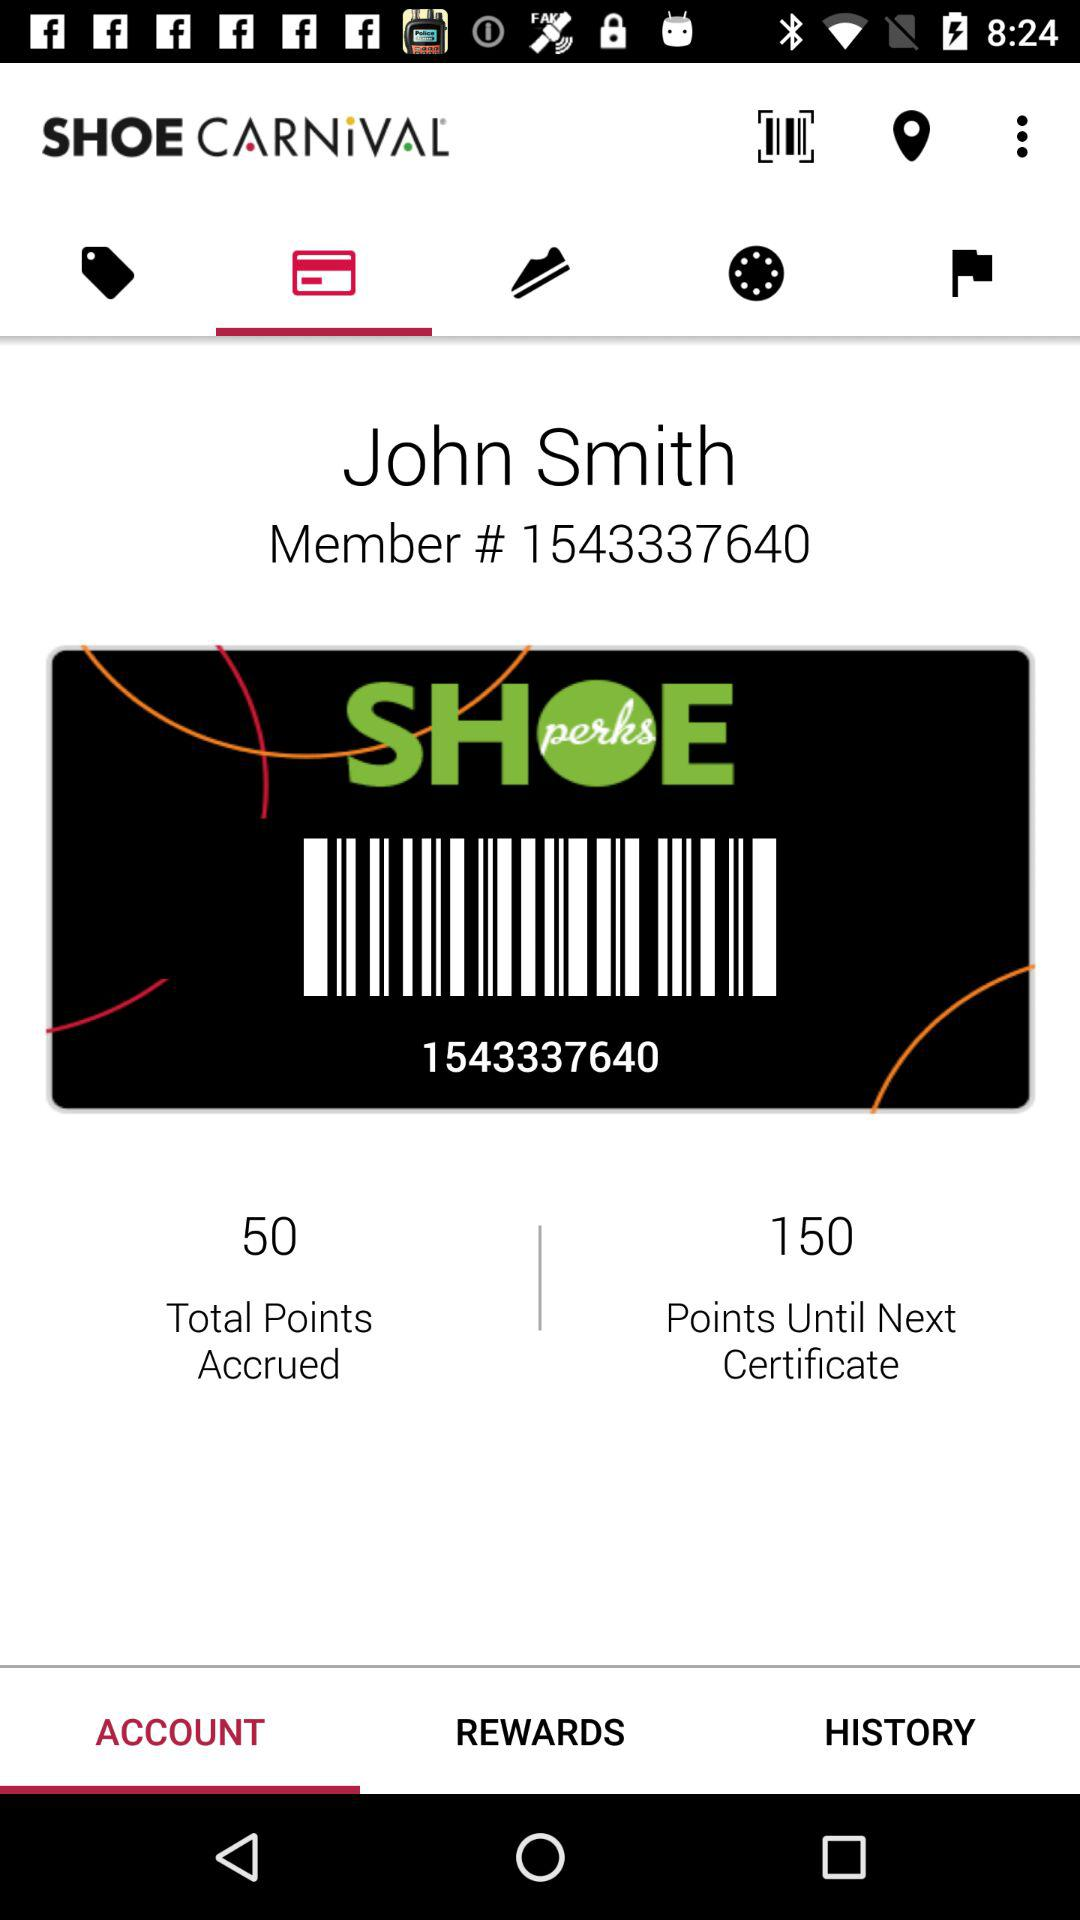How many points are needed to redeem the next certificate?
Answer the question using a single word or phrase. 150 